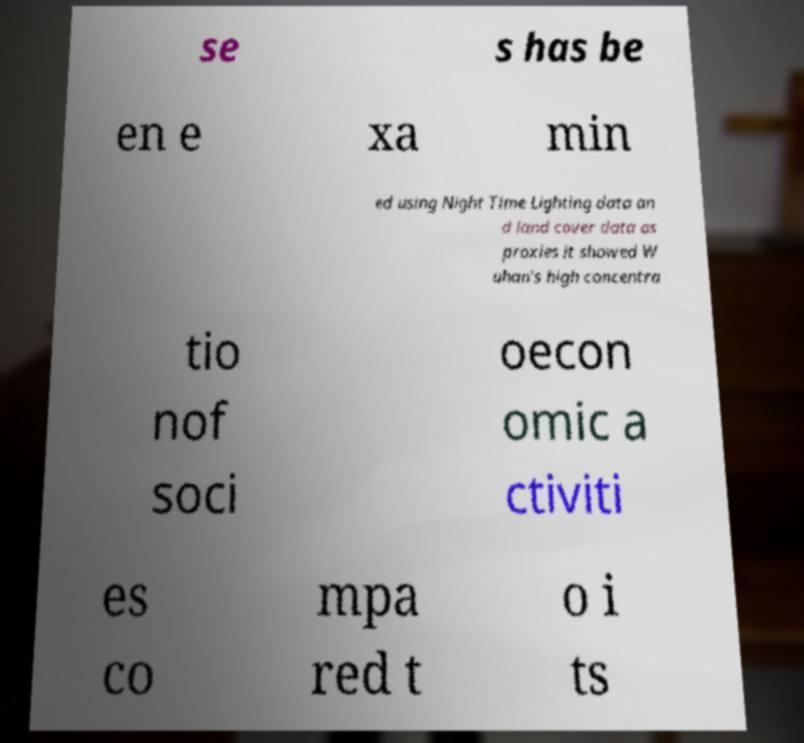Can you accurately transcribe the text from the provided image for me? se s has be en e xa min ed using Night Time Lighting data an d land cover data as proxies it showed W uhan's high concentra tio nof soci oecon omic a ctiviti es co mpa red t o i ts 